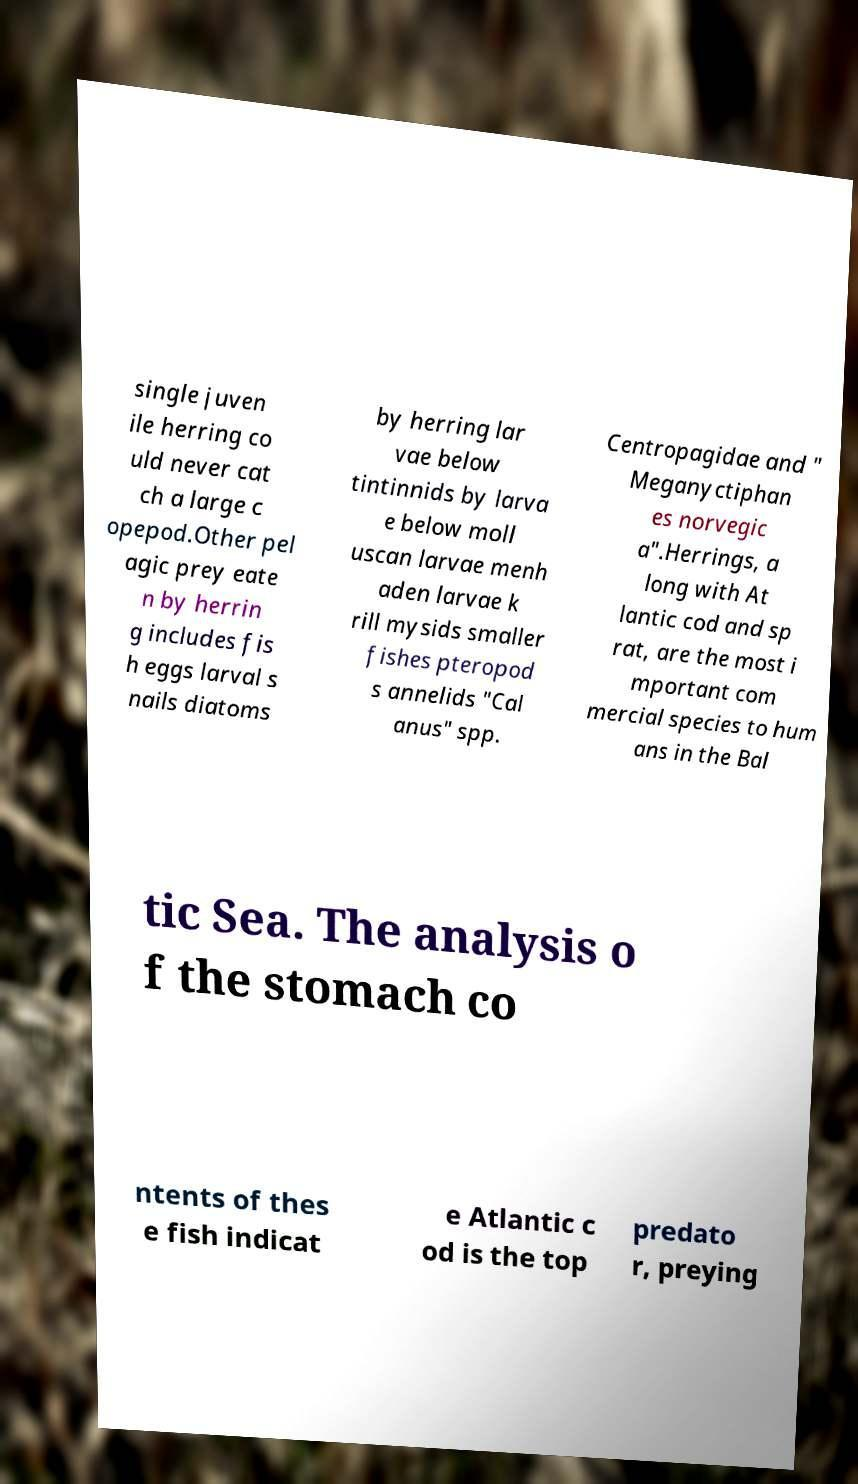Could you assist in decoding the text presented in this image and type it out clearly? single juven ile herring co uld never cat ch a large c opepod.Other pel agic prey eate n by herrin g includes fis h eggs larval s nails diatoms by herring lar vae below tintinnids by larva e below moll uscan larvae menh aden larvae k rill mysids smaller fishes pteropod s annelids "Cal anus" spp. Centropagidae and " Meganyctiphan es norvegic a".Herrings, a long with At lantic cod and sp rat, are the most i mportant com mercial species to hum ans in the Bal tic Sea. The analysis o f the stomach co ntents of thes e fish indicat e Atlantic c od is the top predato r, preying 